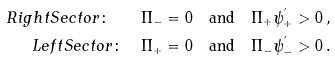Convert formula to latex. <formula><loc_0><loc_0><loc_500><loc_500>R i g h t S e c t o r \colon \quad \Pi _ { - } & = 0 \quad \text {and} \quad \Pi _ { + } \psi _ { + } ^ { ^ { \prime } } > 0 \, , \\ L e f t S e c t o r \colon \quad \Pi _ { + } & = 0 \quad \text {and} \quad \Pi _ { - } \psi _ { - } ^ { ^ { \prime } } > 0 \, .</formula> 